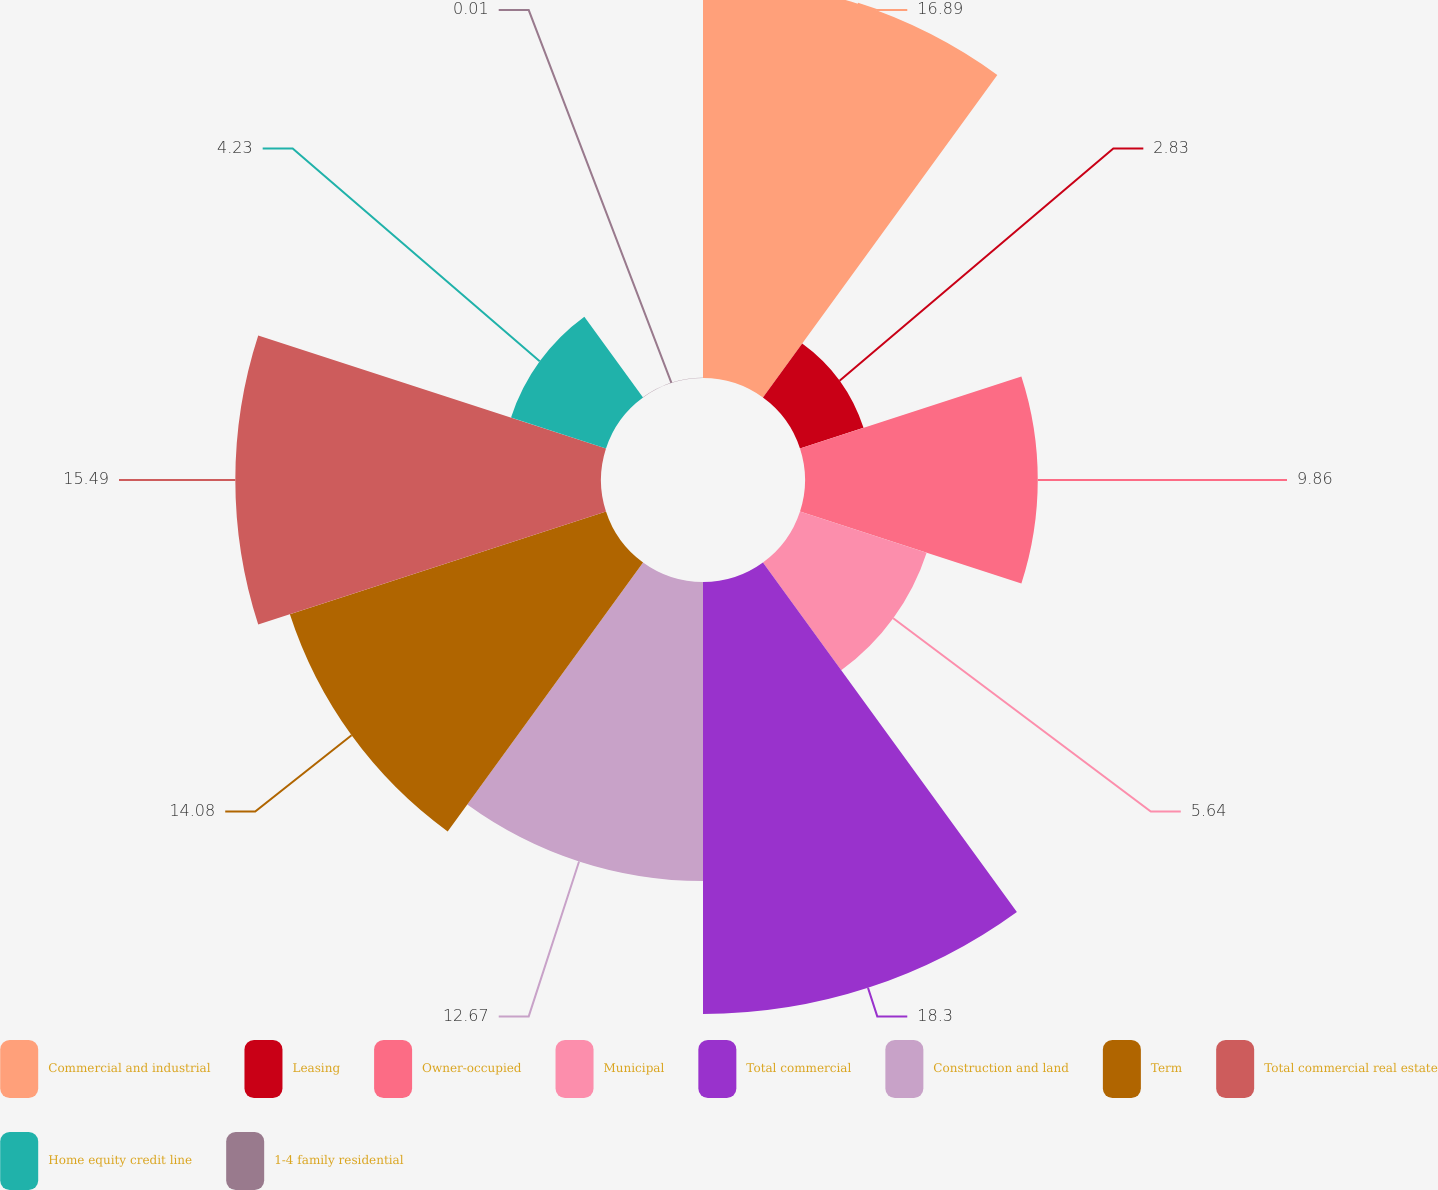Convert chart. <chart><loc_0><loc_0><loc_500><loc_500><pie_chart><fcel>Commercial and industrial<fcel>Leasing<fcel>Owner-occupied<fcel>Municipal<fcel>Total commercial<fcel>Construction and land<fcel>Term<fcel>Total commercial real estate<fcel>Home equity credit line<fcel>1-4 family residential<nl><fcel>16.89%<fcel>2.83%<fcel>9.86%<fcel>5.64%<fcel>18.3%<fcel>12.67%<fcel>14.08%<fcel>15.49%<fcel>4.23%<fcel>0.01%<nl></chart> 